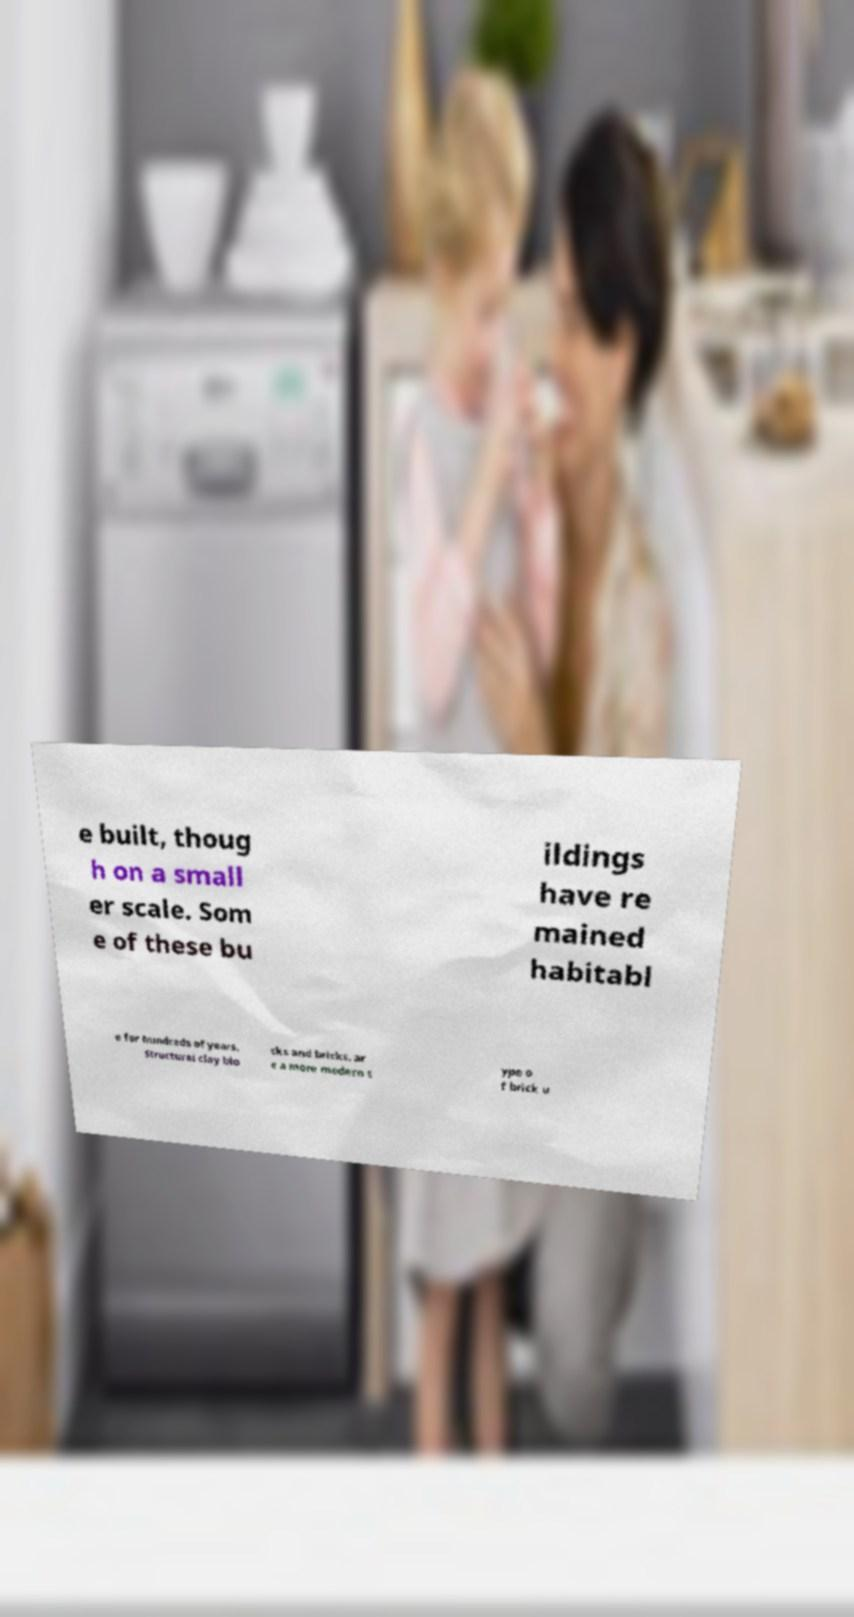There's text embedded in this image that I need extracted. Can you transcribe it verbatim? e built, thoug h on a small er scale. Som e of these bu ildings have re mained habitabl e for hundreds of years. Structural clay blo cks and bricks. ar e a more modern t ype o f brick u 